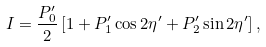Convert formula to latex. <formula><loc_0><loc_0><loc_500><loc_500>I = \frac { P ^ { \prime } _ { 0 } } { 2 } \left [ 1 + P ^ { \prime } _ { 1 } \cos 2 \eta ^ { \prime } + P ^ { \prime } _ { 2 } \sin 2 \eta ^ { \prime } \right ] ,</formula> 